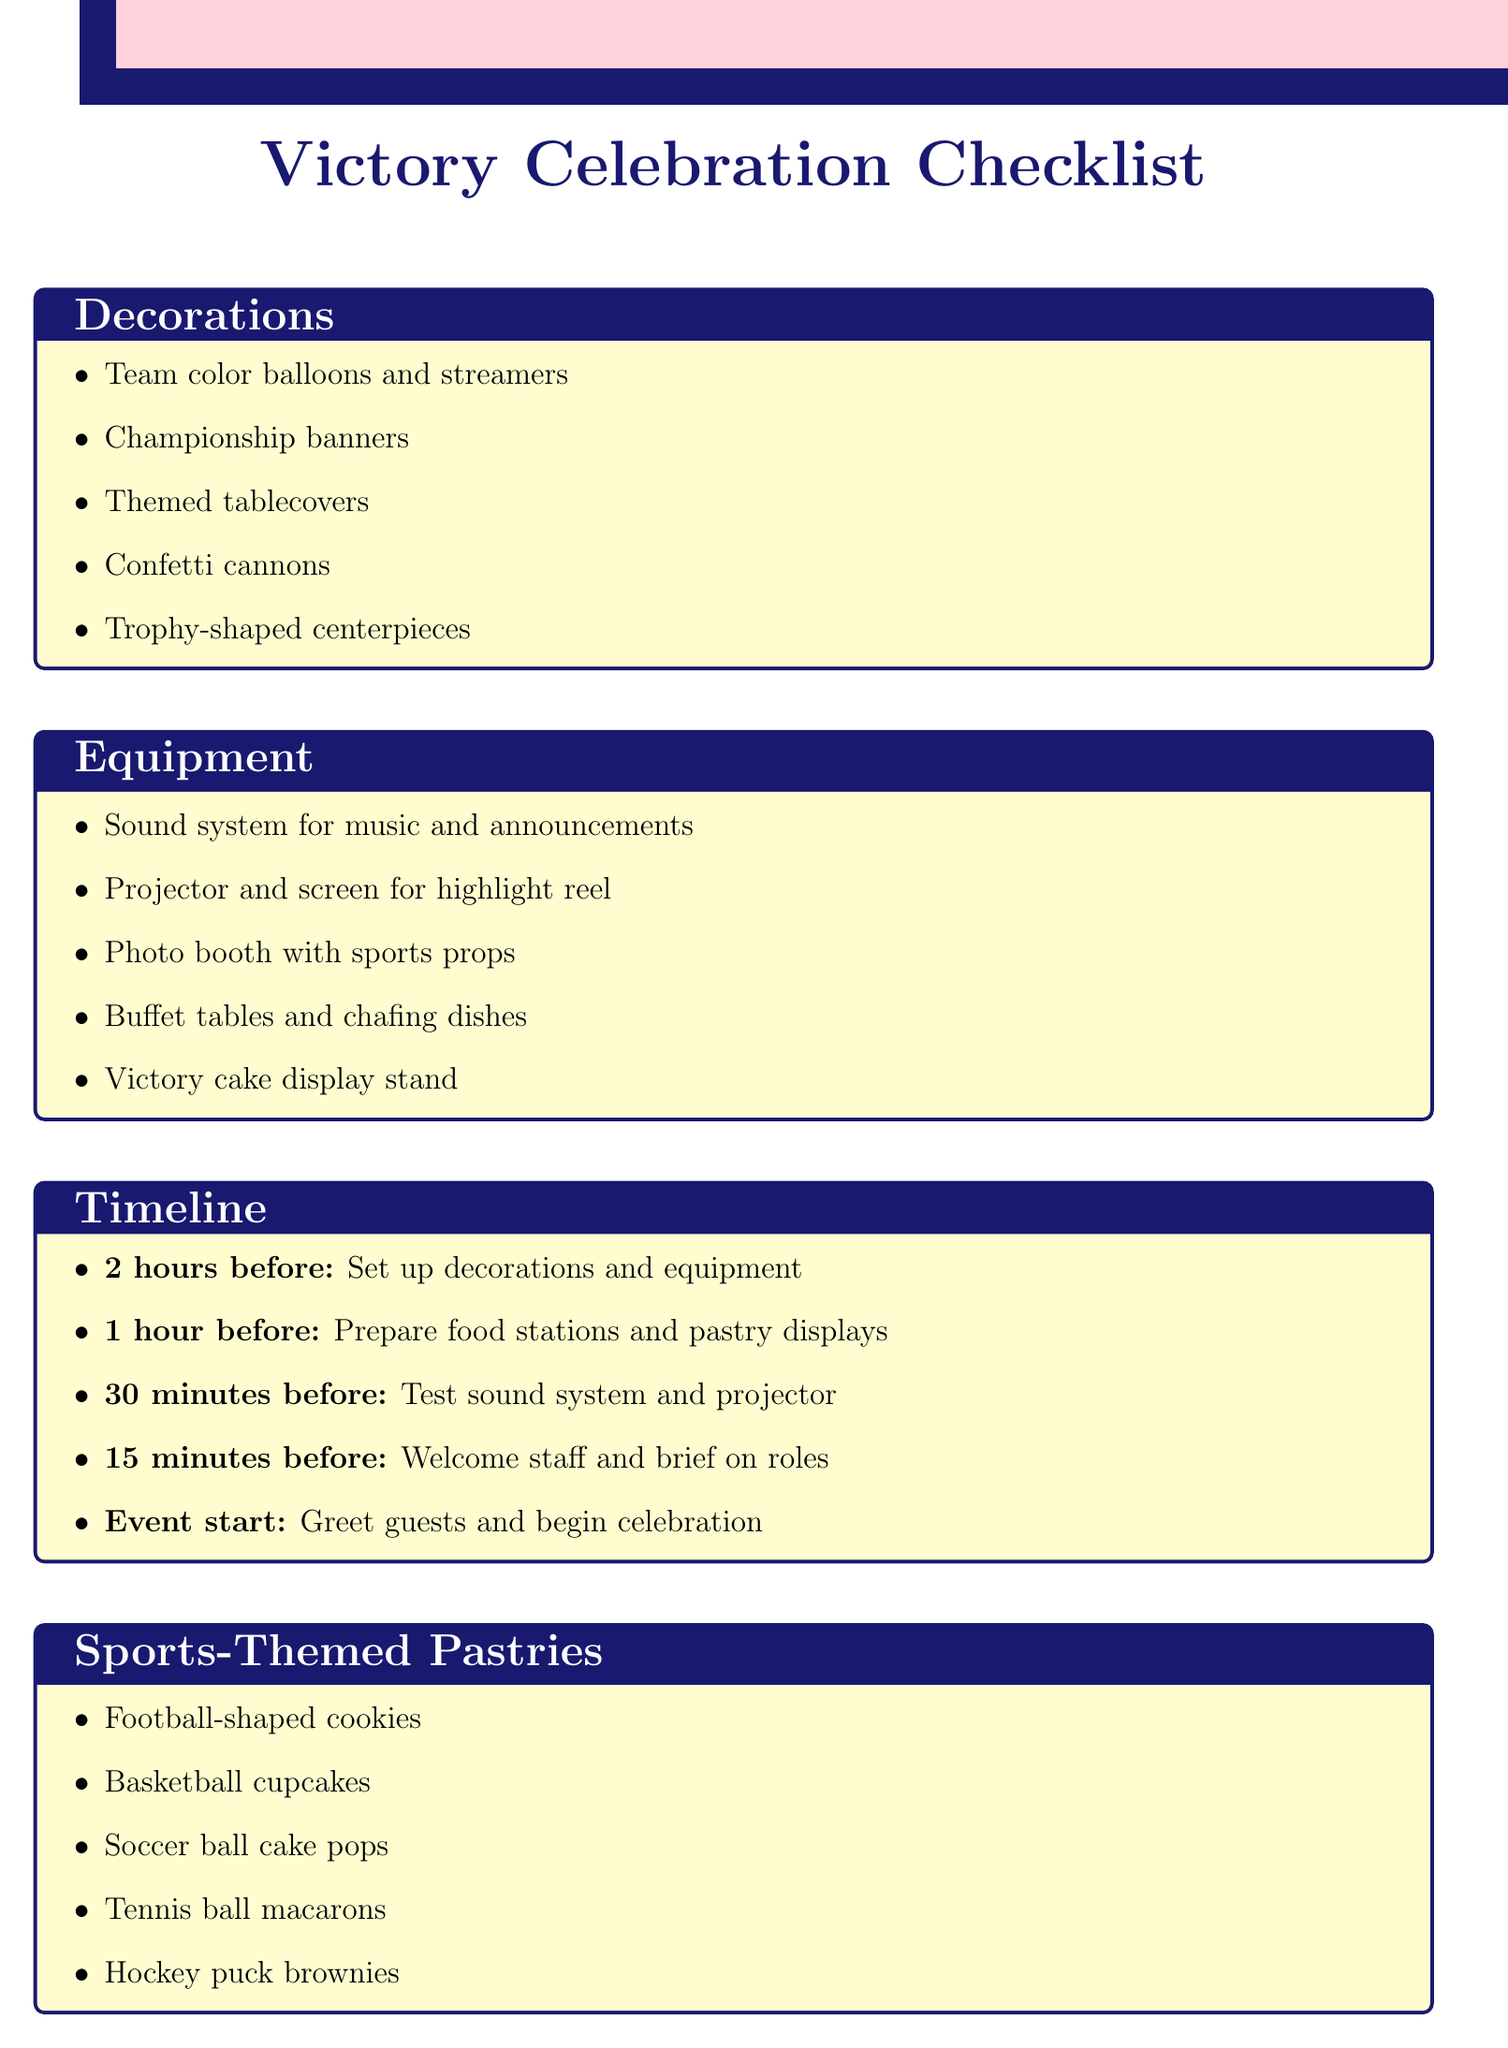What are the colors of the decorations? The decorations include team color balloons and streamers which refer to the colors associated with the team.
Answer: Team colors How many items are listed under Equipment? The Equipment section lists five different items that are necessary for the event.
Answer: 5 What is scheduled 30 minutes before the event? According to the timeline, testing of the sound system and projector is planned to ensure everything is ready.
Answer: Test sound system and projector What category includes trophy-shaped centerpieces? The trophy-shaped centerpieces mentioned in the checklist fall under the category of Decorations.
Answer: Decorations Which pastry resembles a hockey puck? The document lists hockey puck brownies as the pastry that is shaped like a hockey puck.
Answer: Hockey puck brownies What task should be done 2 hours before the event? The task prescribed for two hours before the event involves setting up decorations and equipment to prepare for guests.
Answer: Set up decorations and equipment How many types of sports-themed pastries are there? The checklist details five different varieties of sports-themed pastries that will be served at the event.
Answer: 5 What additional consideration involves a merchandise booth? The document states that setting up a merchandise booth for commemorative items is included as an additional consideration.
Answer: Merchandise booth What is the final task listed in the timeline? The timeline concludes with the action of greeting guests and beginning the celebration at the event start time.
Answer: Greet guests and begin celebration 